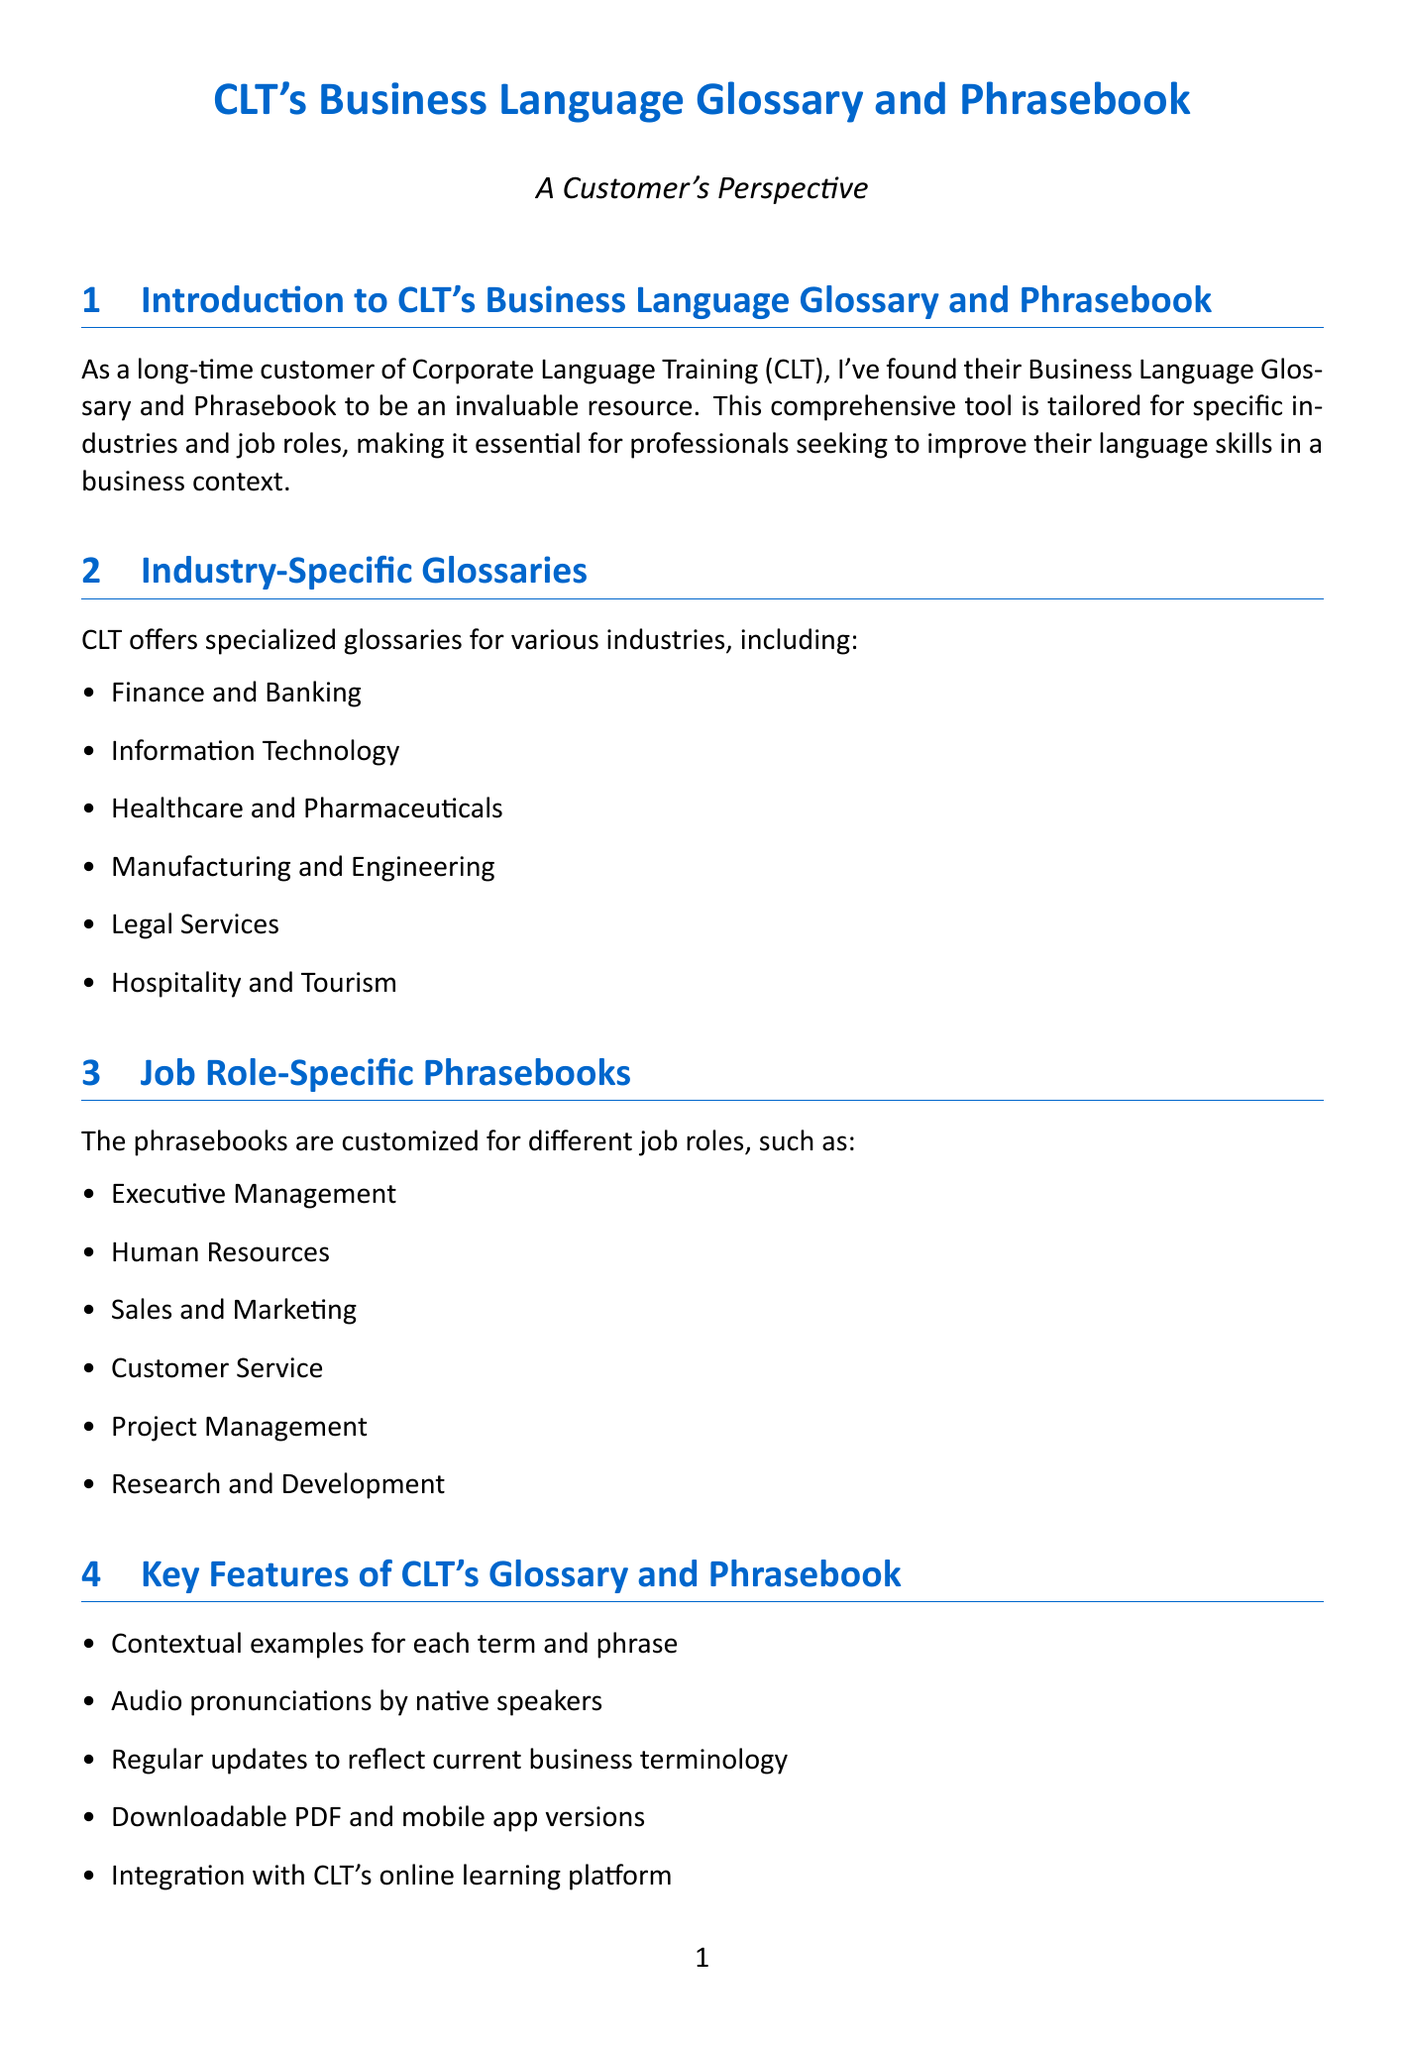What industries are covered in CLT's glossaries? The document lists the specific industries that CLT's glossaries cover for specialized language learning.
Answer: Finance and Banking, Information Technology, Healthcare and Pharmaceuticals, Manufacturing and Engineering, Legal Services, Hospitality and Tourism How many job roles are mentioned in the phrasebooks section? The document explicitly states the number of job roles for which phrasebooks are customized.
Answer: Six What is one of the key features of CLT's glossary? The document outlines several features of CLT's glossary and phrasebook; a common feature is found among these listings.
Answer: Contextual examples for each term and phrase What type of approach does CLT use to improve communication skills? The document discusses the integration of various training services provided by CLT.
Answer: Holistic approach Which financial term is specifically mentioned as part of the Finance glossary? The case study provided includes distinct financial terminology for context.
Answer: Derivatives What is notable about the digital platform of CLT's glossary? The document emphasizes usability aspects of the digital platform for ease of access.
Answer: Intuitive search function Where did the case study referenced in the document take place? The case study mentions a specific organization relevant to the finance sector.
Answer: Goldman Sachs Does CLT provide customization options for glossaries? The document confirms whether CLT allows for tailored language resources to meet specific needs.
Answer: Yes 